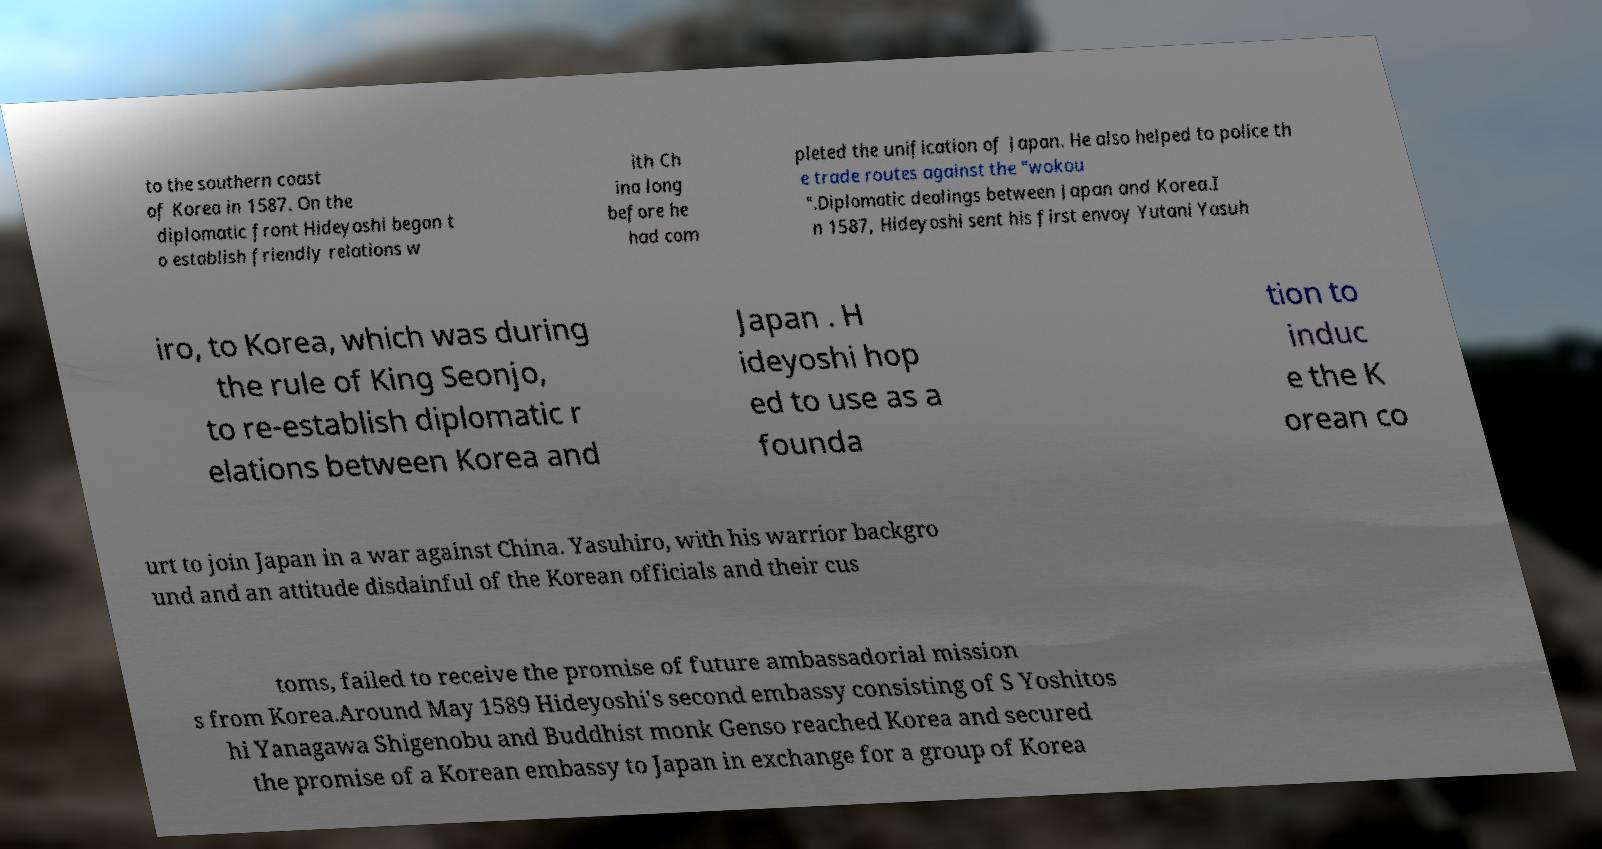There's text embedded in this image that I need extracted. Can you transcribe it verbatim? to the southern coast of Korea in 1587. On the diplomatic front Hideyoshi began t o establish friendly relations w ith Ch ina long before he had com pleted the unification of Japan. He also helped to police th e trade routes against the "wokou ".Diplomatic dealings between Japan and Korea.I n 1587, Hideyoshi sent his first envoy Yutani Yasuh iro, to Korea, which was during the rule of King Seonjo, to re-establish diplomatic r elations between Korea and Japan . H ideyoshi hop ed to use as a founda tion to induc e the K orean co urt to join Japan in a war against China. Yasuhiro, with his warrior backgro und and an attitude disdainful of the Korean officials and their cus toms, failed to receive the promise of future ambassadorial mission s from Korea.Around May 1589 Hideyoshi's second embassy consisting of S Yoshitos hi Yanagawa Shigenobu and Buddhist monk Genso reached Korea and secured the promise of a Korean embassy to Japan in exchange for a group of Korea 